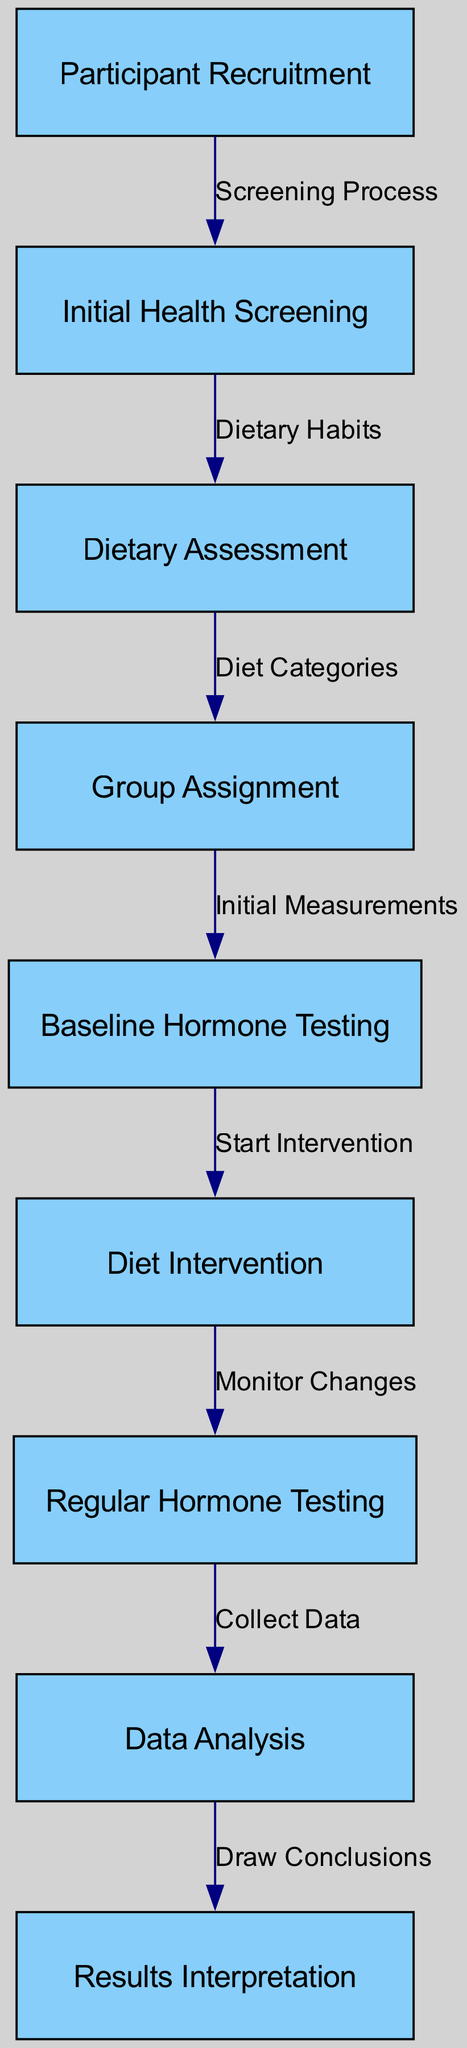What is the first step in the process flow? The first node in the diagram is "Participant Recruitment". It is the starting point and sets the direction for all subsequent steps in the flowchart.
Answer: Participant Recruitment How many nodes are present in the diagram? The diagram lists a total of 9 unique nodes that represent different steps in the longitudinal study process.
Answer: 9 What type of process follows the Initial Health Screening? The arrow from "Initial Health Screening" to "Dietary Assessment" indicates that the next step is dictated by the outcomes of the health screening, specifically leading into a dietary habits assessment.
Answer: Dietary Assessment Which node represents the stage where participants receive their dietary interventions? The node labeled "Diet Intervention" signifies the step where dietary changes are implemented based on the group assignments from previous assessments.
Answer: Diet Intervention How many edges connect the nodes in this diagram? By counting the directed edges that connect the nodes, there are a total of 8 edges that show the flow from one node to another in the study.
Answer: 8 What do the edges between the nodes represent? Each edge represents the relationship and flow of the process from one step to the next, indicating how each step relates to and impacts the subsequent step in the study.
Answer: Relationship What follows the "Regular Hormone Testing" in the process flow? The arrow from "Regular Hormone Testing" leads to "Data Analysis", indicating that after regular tests, the collected hormonal data will be analyzed.
Answer: Data Analysis What is the last step in the longitudinal study process according to the diagram? The last node is "Results Interpretation" which signifies that after data analysis, the results will be interpreted to draw final conclusions from the study.
Answer: Results Interpretation What is the nature of the connection between "Dietary Assessment" and "Group Assignment"? The edge labeled "Diet Categories" signifies that the dietary assessment informs how participants are grouped for the study as per the categories defined by their dietary habits.
Answer: Diet Categories What is the purpose of the "Baseline Hormone Testing" node? "Baseline Hormone Testing" acts as an initial measurement stage to understand hormonal levels before any intervention begins, providing a comparison point for future tests.
Answer: Initial Measurements 